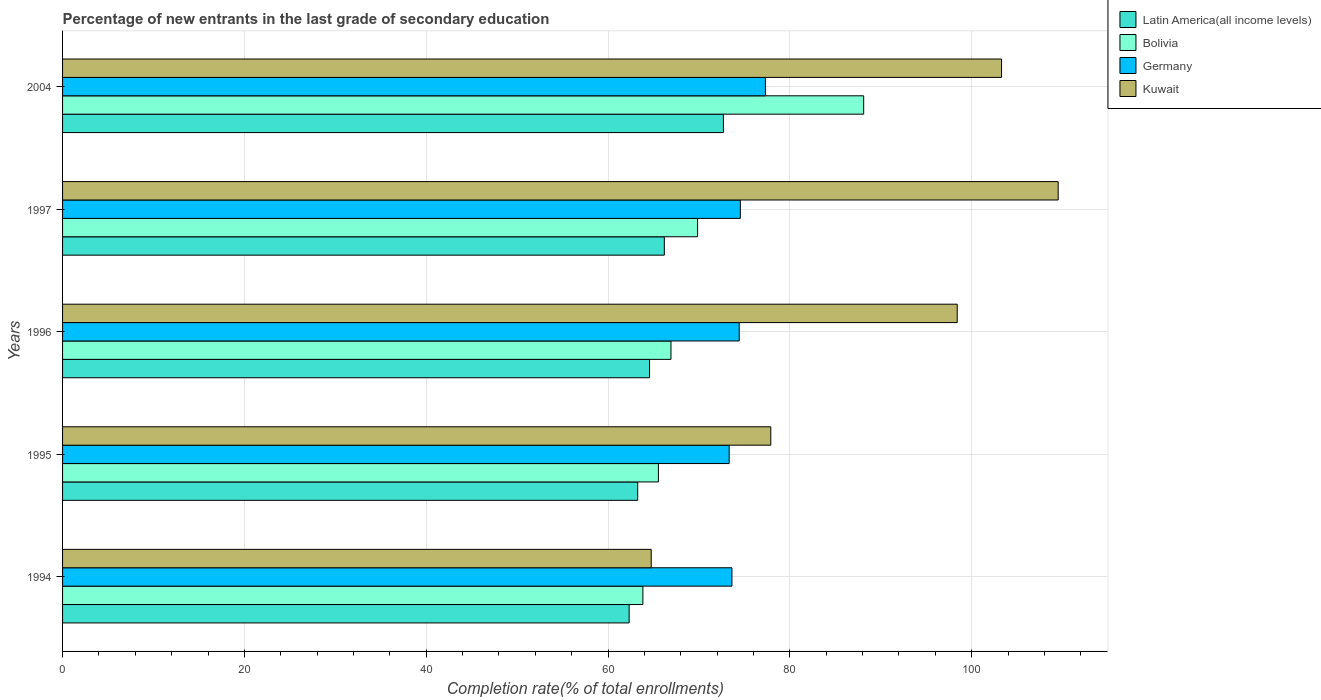How many different coloured bars are there?
Offer a terse response. 4. How many groups of bars are there?
Provide a succinct answer. 5. Are the number of bars on each tick of the Y-axis equal?
Keep it short and to the point. Yes. How many bars are there on the 4th tick from the bottom?
Give a very brief answer. 4. What is the label of the 4th group of bars from the top?
Offer a terse response. 1995. In how many cases, is the number of bars for a given year not equal to the number of legend labels?
Your response must be concise. 0. What is the percentage of new entrants in Kuwait in 1994?
Your answer should be very brief. 64.75. Across all years, what is the maximum percentage of new entrants in Germany?
Provide a succinct answer. 77.31. Across all years, what is the minimum percentage of new entrants in Germany?
Make the answer very short. 73.32. What is the total percentage of new entrants in Germany in the graph?
Offer a terse response. 373.24. What is the difference between the percentage of new entrants in Bolivia in 1997 and that in 2004?
Your answer should be very brief. -18.27. What is the difference between the percentage of new entrants in Kuwait in 1994 and the percentage of new entrants in Latin America(all income levels) in 1996?
Your answer should be very brief. 0.18. What is the average percentage of new entrants in Latin America(all income levels) per year?
Provide a short and direct response. 65.81. In the year 1994, what is the difference between the percentage of new entrants in Bolivia and percentage of new entrants in Germany?
Give a very brief answer. -9.79. What is the ratio of the percentage of new entrants in Kuwait in 1997 to that in 2004?
Provide a short and direct response. 1.06. What is the difference between the highest and the second highest percentage of new entrants in Kuwait?
Provide a short and direct response. 6.23. What is the difference between the highest and the lowest percentage of new entrants in Latin America(all income levels)?
Ensure brevity in your answer.  10.37. Is the sum of the percentage of new entrants in Latin America(all income levels) in 1995 and 1997 greater than the maximum percentage of new entrants in Bolivia across all years?
Make the answer very short. Yes. Is it the case that in every year, the sum of the percentage of new entrants in Latin America(all income levels) and percentage of new entrants in Germany is greater than the sum of percentage of new entrants in Kuwait and percentage of new entrants in Bolivia?
Your response must be concise. No. What does the 4th bar from the top in 2004 represents?
Your answer should be compact. Latin America(all income levels). What does the 2nd bar from the bottom in 1996 represents?
Your answer should be very brief. Bolivia. Are all the bars in the graph horizontal?
Provide a short and direct response. Yes. How many years are there in the graph?
Give a very brief answer. 5. What is the difference between two consecutive major ticks on the X-axis?
Provide a succinct answer. 20. Are the values on the major ticks of X-axis written in scientific E-notation?
Keep it short and to the point. No. Does the graph contain any zero values?
Your answer should be very brief. No. Does the graph contain grids?
Offer a terse response. Yes. How are the legend labels stacked?
Make the answer very short. Vertical. What is the title of the graph?
Make the answer very short. Percentage of new entrants in the last grade of secondary education. Does "Cuba" appear as one of the legend labels in the graph?
Offer a very short reply. No. What is the label or title of the X-axis?
Offer a very short reply. Completion rate(% of total enrollments). What is the Completion rate(% of total enrollments) in Latin America(all income levels) in 1994?
Your answer should be very brief. 62.32. What is the Completion rate(% of total enrollments) in Bolivia in 1994?
Give a very brief answer. 63.83. What is the Completion rate(% of total enrollments) of Germany in 1994?
Your answer should be very brief. 73.63. What is the Completion rate(% of total enrollments) in Kuwait in 1994?
Your answer should be compact. 64.75. What is the Completion rate(% of total enrollments) in Latin America(all income levels) in 1995?
Your answer should be very brief. 63.26. What is the Completion rate(% of total enrollments) of Bolivia in 1995?
Offer a very short reply. 65.54. What is the Completion rate(% of total enrollments) in Germany in 1995?
Your response must be concise. 73.32. What is the Completion rate(% of total enrollments) in Kuwait in 1995?
Give a very brief answer. 77.9. What is the Completion rate(% of total enrollments) in Latin America(all income levels) in 1996?
Offer a terse response. 64.57. What is the Completion rate(% of total enrollments) of Bolivia in 1996?
Keep it short and to the point. 66.92. What is the Completion rate(% of total enrollments) of Germany in 1996?
Your answer should be compact. 74.43. What is the Completion rate(% of total enrollments) of Kuwait in 1996?
Give a very brief answer. 98.41. What is the Completion rate(% of total enrollments) of Latin America(all income levels) in 1997?
Your answer should be compact. 66.19. What is the Completion rate(% of total enrollments) in Bolivia in 1997?
Provide a short and direct response. 69.85. What is the Completion rate(% of total enrollments) of Germany in 1997?
Your answer should be very brief. 74.55. What is the Completion rate(% of total enrollments) in Kuwait in 1997?
Offer a very short reply. 109.51. What is the Completion rate(% of total enrollments) of Latin America(all income levels) in 2004?
Provide a succinct answer. 72.69. What is the Completion rate(% of total enrollments) in Bolivia in 2004?
Provide a short and direct response. 88.12. What is the Completion rate(% of total enrollments) in Germany in 2004?
Keep it short and to the point. 77.31. What is the Completion rate(% of total enrollments) in Kuwait in 2004?
Offer a very short reply. 103.29. Across all years, what is the maximum Completion rate(% of total enrollments) of Latin America(all income levels)?
Your response must be concise. 72.69. Across all years, what is the maximum Completion rate(% of total enrollments) in Bolivia?
Provide a short and direct response. 88.12. Across all years, what is the maximum Completion rate(% of total enrollments) of Germany?
Provide a short and direct response. 77.31. Across all years, what is the maximum Completion rate(% of total enrollments) of Kuwait?
Provide a short and direct response. 109.51. Across all years, what is the minimum Completion rate(% of total enrollments) in Latin America(all income levels)?
Your answer should be very brief. 62.32. Across all years, what is the minimum Completion rate(% of total enrollments) of Bolivia?
Your answer should be compact. 63.83. Across all years, what is the minimum Completion rate(% of total enrollments) of Germany?
Provide a short and direct response. 73.32. Across all years, what is the minimum Completion rate(% of total enrollments) of Kuwait?
Make the answer very short. 64.75. What is the total Completion rate(% of total enrollments) of Latin America(all income levels) in the graph?
Your response must be concise. 329.04. What is the total Completion rate(% of total enrollments) in Bolivia in the graph?
Keep it short and to the point. 354.27. What is the total Completion rate(% of total enrollments) of Germany in the graph?
Offer a very short reply. 373.24. What is the total Completion rate(% of total enrollments) in Kuwait in the graph?
Make the answer very short. 453.86. What is the difference between the Completion rate(% of total enrollments) in Latin America(all income levels) in 1994 and that in 1995?
Provide a short and direct response. -0.94. What is the difference between the Completion rate(% of total enrollments) of Bolivia in 1994 and that in 1995?
Provide a short and direct response. -1.71. What is the difference between the Completion rate(% of total enrollments) of Germany in 1994 and that in 1995?
Ensure brevity in your answer.  0.3. What is the difference between the Completion rate(% of total enrollments) in Kuwait in 1994 and that in 1995?
Offer a terse response. -13.15. What is the difference between the Completion rate(% of total enrollments) in Latin America(all income levels) in 1994 and that in 1996?
Your answer should be very brief. -2.25. What is the difference between the Completion rate(% of total enrollments) of Bolivia in 1994 and that in 1996?
Your answer should be compact. -3.09. What is the difference between the Completion rate(% of total enrollments) of Germany in 1994 and that in 1996?
Ensure brevity in your answer.  -0.8. What is the difference between the Completion rate(% of total enrollments) in Kuwait in 1994 and that in 1996?
Make the answer very short. -33.66. What is the difference between the Completion rate(% of total enrollments) in Latin America(all income levels) in 1994 and that in 1997?
Your response must be concise. -3.87. What is the difference between the Completion rate(% of total enrollments) of Bolivia in 1994 and that in 1997?
Keep it short and to the point. -6.02. What is the difference between the Completion rate(% of total enrollments) in Germany in 1994 and that in 1997?
Your answer should be very brief. -0.93. What is the difference between the Completion rate(% of total enrollments) in Kuwait in 1994 and that in 1997?
Make the answer very short. -44.76. What is the difference between the Completion rate(% of total enrollments) in Latin America(all income levels) in 1994 and that in 2004?
Your response must be concise. -10.37. What is the difference between the Completion rate(% of total enrollments) of Bolivia in 1994 and that in 2004?
Offer a very short reply. -24.29. What is the difference between the Completion rate(% of total enrollments) in Germany in 1994 and that in 2004?
Your response must be concise. -3.68. What is the difference between the Completion rate(% of total enrollments) of Kuwait in 1994 and that in 2004?
Provide a short and direct response. -38.54. What is the difference between the Completion rate(% of total enrollments) of Latin America(all income levels) in 1995 and that in 1996?
Your answer should be compact. -1.3. What is the difference between the Completion rate(% of total enrollments) in Bolivia in 1995 and that in 1996?
Make the answer very short. -1.38. What is the difference between the Completion rate(% of total enrollments) in Germany in 1995 and that in 1996?
Your answer should be very brief. -1.1. What is the difference between the Completion rate(% of total enrollments) of Kuwait in 1995 and that in 1996?
Ensure brevity in your answer.  -20.51. What is the difference between the Completion rate(% of total enrollments) of Latin America(all income levels) in 1995 and that in 1997?
Give a very brief answer. -2.93. What is the difference between the Completion rate(% of total enrollments) in Bolivia in 1995 and that in 1997?
Your answer should be very brief. -4.31. What is the difference between the Completion rate(% of total enrollments) of Germany in 1995 and that in 1997?
Offer a terse response. -1.23. What is the difference between the Completion rate(% of total enrollments) in Kuwait in 1995 and that in 1997?
Offer a terse response. -31.61. What is the difference between the Completion rate(% of total enrollments) of Latin America(all income levels) in 1995 and that in 2004?
Your response must be concise. -9.43. What is the difference between the Completion rate(% of total enrollments) of Bolivia in 1995 and that in 2004?
Provide a short and direct response. -22.58. What is the difference between the Completion rate(% of total enrollments) in Germany in 1995 and that in 2004?
Provide a succinct answer. -3.98. What is the difference between the Completion rate(% of total enrollments) of Kuwait in 1995 and that in 2004?
Your answer should be compact. -25.38. What is the difference between the Completion rate(% of total enrollments) of Latin America(all income levels) in 1996 and that in 1997?
Give a very brief answer. -1.62. What is the difference between the Completion rate(% of total enrollments) of Bolivia in 1996 and that in 1997?
Offer a very short reply. -2.93. What is the difference between the Completion rate(% of total enrollments) in Germany in 1996 and that in 1997?
Your answer should be compact. -0.13. What is the difference between the Completion rate(% of total enrollments) of Kuwait in 1996 and that in 1997?
Give a very brief answer. -11.1. What is the difference between the Completion rate(% of total enrollments) of Latin America(all income levels) in 1996 and that in 2004?
Offer a terse response. -8.12. What is the difference between the Completion rate(% of total enrollments) in Bolivia in 1996 and that in 2004?
Keep it short and to the point. -21.2. What is the difference between the Completion rate(% of total enrollments) of Germany in 1996 and that in 2004?
Offer a very short reply. -2.88. What is the difference between the Completion rate(% of total enrollments) of Kuwait in 1996 and that in 2004?
Ensure brevity in your answer.  -4.88. What is the difference between the Completion rate(% of total enrollments) in Latin America(all income levels) in 1997 and that in 2004?
Provide a short and direct response. -6.5. What is the difference between the Completion rate(% of total enrollments) of Bolivia in 1997 and that in 2004?
Your answer should be very brief. -18.27. What is the difference between the Completion rate(% of total enrollments) of Germany in 1997 and that in 2004?
Your answer should be compact. -2.75. What is the difference between the Completion rate(% of total enrollments) in Kuwait in 1997 and that in 2004?
Keep it short and to the point. 6.23. What is the difference between the Completion rate(% of total enrollments) of Latin America(all income levels) in 1994 and the Completion rate(% of total enrollments) of Bolivia in 1995?
Your response must be concise. -3.22. What is the difference between the Completion rate(% of total enrollments) of Latin America(all income levels) in 1994 and the Completion rate(% of total enrollments) of Germany in 1995?
Your answer should be compact. -11. What is the difference between the Completion rate(% of total enrollments) of Latin America(all income levels) in 1994 and the Completion rate(% of total enrollments) of Kuwait in 1995?
Your answer should be very brief. -15.58. What is the difference between the Completion rate(% of total enrollments) in Bolivia in 1994 and the Completion rate(% of total enrollments) in Germany in 1995?
Keep it short and to the point. -9.49. What is the difference between the Completion rate(% of total enrollments) in Bolivia in 1994 and the Completion rate(% of total enrollments) in Kuwait in 1995?
Provide a succinct answer. -14.07. What is the difference between the Completion rate(% of total enrollments) of Germany in 1994 and the Completion rate(% of total enrollments) of Kuwait in 1995?
Your response must be concise. -4.28. What is the difference between the Completion rate(% of total enrollments) in Latin America(all income levels) in 1994 and the Completion rate(% of total enrollments) in Bolivia in 1996?
Make the answer very short. -4.6. What is the difference between the Completion rate(% of total enrollments) of Latin America(all income levels) in 1994 and the Completion rate(% of total enrollments) of Germany in 1996?
Ensure brevity in your answer.  -12.11. What is the difference between the Completion rate(% of total enrollments) of Latin America(all income levels) in 1994 and the Completion rate(% of total enrollments) of Kuwait in 1996?
Ensure brevity in your answer.  -36.09. What is the difference between the Completion rate(% of total enrollments) of Bolivia in 1994 and the Completion rate(% of total enrollments) of Germany in 1996?
Keep it short and to the point. -10.59. What is the difference between the Completion rate(% of total enrollments) of Bolivia in 1994 and the Completion rate(% of total enrollments) of Kuwait in 1996?
Your answer should be compact. -34.58. What is the difference between the Completion rate(% of total enrollments) in Germany in 1994 and the Completion rate(% of total enrollments) in Kuwait in 1996?
Offer a very short reply. -24.78. What is the difference between the Completion rate(% of total enrollments) of Latin America(all income levels) in 1994 and the Completion rate(% of total enrollments) of Bolivia in 1997?
Your answer should be compact. -7.53. What is the difference between the Completion rate(% of total enrollments) of Latin America(all income levels) in 1994 and the Completion rate(% of total enrollments) of Germany in 1997?
Offer a terse response. -12.23. What is the difference between the Completion rate(% of total enrollments) of Latin America(all income levels) in 1994 and the Completion rate(% of total enrollments) of Kuwait in 1997?
Make the answer very short. -47.19. What is the difference between the Completion rate(% of total enrollments) in Bolivia in 1994 and the Completion rate(% of total enrollments) in Germany in 1997?
Provide a short and direct response. -10.72. What is the difference between the Completion rate(% of total enrollments) in Bolivia in 1994 and the Completion rate(% of total enrollments) in Kuwait in 1997?
Keep it short and to the point. -45.68. What is the difference between the Completion rate(% of total enrollments) of Germany in 1994 and the Completion rate(% of total enrollments) of Kuwait in 1997?
Provide a short and direct response. -35.88. What is the difference between the Completion rate(% of total enrollments) in Latin America(all income levels) in 1994 and the Completion rate(% of total enrollments) in Bolivia in 2004?
Provide a short and direct response. -25.8. What is the difference between the Completion rate(% of total enrollments) of Latin America(all income levels) in 1994 and the Completion rate(% of total enrollments) of Germany in 2004?
Offer a terse response. -14.99. What is the difference between the Completion rate(% of total enrollments) in Latin America(all income levels) in 1994 and the Completion rate(% of total enrollments) in Kuwait in 2004?
Provide a succinct answer. -40.96. What is the difference between the Completion rate(% of total enrollments) of Bolivia in 1994 and the Completion rate(% of total enrollments) of Germany in 2004?
Provide a short and direct response. -13.47. What is the difference between the Completion rate(% of total enrollments) of Bolivia in 1994 and the Completion rate(% of total enrollments) of Kuwait in 2004?
Your response must be concise. -39.45. What is the difference between the Completion rate(% of total enrollments) of Germany in 1994 and the Completion rate(% of total enrollments) of Kuwait in 2004?
Offer a terse response. -29.66. What is the difference between the Completion rate(% of total enrollments) in Latin America(all income levels) in 1995 and the Completion rate(% of total enrollments) in Bolivia in 1996?
Your answer should be very brief. -3.66. What is the difference between the Completion rate(% of total enrollments) in Latin America(all income levels) in 1995 and the Completion rate(% of total enrollments) in Germany in 1996?
Make the answer very short. -11.16. What is the difference between the Completion rate(% of total enrollments) of Latin America(all income levels) in 1995 and the Completion rate(% of total enrollments) of Kuwait in 1996?
Give a very brief answer. -35.15. What is the difference between the Completion rate(% of total enrollments) in Bolivia in 1995 and the Completion rate(% of total enrollments) in Germany in 1996?
Give a very brief answer. -8.89. What is the difference between the Completion rate(% of total enrollments) in Bolivia in 1995 and the Completion rate(% of total enrollments) in Kuwait in 1996?
Provide a short and direct response. -32.87. What is the difference between the Completion rate(% of total enrollments) of Germany in 1995 and the Completion rate(% of total enrollments) of Kuwait in 1996?
Keep it short and to the point. -25.09. What is the difference between the Completion rate(% of total enrollments) in Latin America(all income levels) in 1995 and the Completion rate(% of total enrollments) in Bolivia in 1997?
Offer a very short reply. -6.59. What is the difference between the Completion rate(% of total enrollments) in Latin America(all income levels) in 1995 and the Completion rate(% of total enrollments) in Germany in 1997?
Provide a short and direct response. -11.29. What is the difference between the Completion rate(% of total enrollments) in Latin America(all income levels) in 1995 and the Completion rate(% of total enrollments) in Kuwait in 1997?
Offer a terse response. -46.25. What is the difference between the Completion rate(% of total enrollments) of Bolivia in 1995 and the Completion rate(% of total enrollments) of Germany in 1997?
Your response must be concise. -9.01. What is the difference between the Completion rate(% of total enrollments) in Bolivia in 1995 and the Completion rate(% of total enrollments) in Kuwait in 1997?
Offer a very short reply. -43.97. What is the difference between the Completion rate(% of total enrollments) in Germany in 1995 and the Completion rate(% of total enrollments) in Kuwait in 1997?
Give a very brief answer. -36.19. What is the difference between the Completion rate(% of total enrollments) of Latin America(all income levels) in 1995 and the Completion rate(% of total enrollments) of Bolivia in 2004?
Make the answer very short. -24.86. What is the difference between the Completion rate(% of total enrollments) in Latin America(all income levels) in 1995 and the Completion rate(% of total enrollments) in Germany in 2004?
Give a very brief answer. -14.04. What is the difference between the Completion rate(% of total enrollments) in Latin America(all income levels) in 1995 and the Completion rate(% of total enrollments) in Kuwait in 2004?
Provide a short and direct response. -40.02. What is the difference between the Completion rate(% of total enrollments) of Bolivia in 1995 and the Completion rate(% of total enrollments) of Germany in 2004?
Make the answer very short. -11.77. What is the difference between the Completion rate(% of total enrollments) in Bolivia in 1995 and the Completion rate(% of total enrollments) in Kuwait in 2004?
Your answer should be compact. -37.75. What is the difference between the Completion rate(% of total enrollments) in Germany in 1995 and the Completion rate(% of total enrollments) in Kuwait in 2004?
Ensure brevity in your answer.  -29.96. What is the difference between the Completion rate(% of total enrollments) of Latin America(all income levels) in 1996 and the Completion rate(% of total enrollments) of Bolivia in 1997?
Provide a short and direct response. -5.28. What is the difference between the Completion rate(% of total enrollments) in Latin America(all income levels) in 1996 and the Completion rate(% of total enrollments) in Germany in 1997?
Offer a terse response. -9.99. What is the difference between the Completion rate(% of total enrollments) in Latin America(all income levels) in 1996 and the Completion rate(% of total enrollments) in Kuwait in 1997?
Provide a succinct answer. -44.95. What is the difference between the Completion rate(% of total enrollments) in Bolivia in 1996 and the Completion rate(% of total enrollments) in Germany in 1997?
Your answer should be very brief. -7.63. What is the difference between the Completion rate(% of total enrollments) in Bolivia in 1996 and the Completion rate(% of total enrollments) in Kuwait in 1997?
Your answer should be compact. -42.59. What is the difference between the Completion rate(% of total enrollments) in Germany in 1996 and the Completion rate(% of total enrollments) in Kuwait in 1997?
Make the answer very short. -35.08. What is the difference between the Completion rate(% of total enrollments) of Latin America(all income levels) in 1996 and the Completion rate(% of total enrollments) of Bolivia in 2004?
Your answer should be very brief. -23.55. What is the difference between the Completion rate(% of total enrollments) of Latin America(all income levels) in 1996 and the Completion rate(% of total enrollments) of Germany in 2004?
Make the answer very short. -12.74. What is the difference between the Completion rate(% of total enrollments) in Latin America(all income levels) in 1996 and the Completion rate(% of total enrollments) in Kuwait in 2004?
Your response must be concise. -38.72. What is the difference between the Completion rate(% of total enrollments) in Bolivia in 1996 and the Completion rate(% of total enrollments) in Germany in 2004?
Provide a short and direct response. -10.39. What is the difference between the Completion rate(% of total enrollments) of Bolivia in 1996 and the Completion rate(% of total enrollments) of Kuwait in 2004?
Give a very brief answer. -36.36. What is the difference between the Completion rate(% of total enrollments) of Germany in 1996 and the Completion rate(% of total enrollments) of Kuwait in 2004?
Provide a short and direct response. -28.86. What is the difference between the Completion rate(% of total enrollments) of Latin America(all income levels) in 1997 and the Completion rate(% of total enrollments) of Bolivia in 2004?
Your response must be concise. -21.93. What is the difference between the Completion rate(% of total enrollments) of Latin America(all income levels) in 1997 and the Completion rate(% of total enrollments) of Germany in 2004?
Keep it short and to the point. -11.12. What is the difference between the Completion rate(% of total enrollments) of Latin America(all income levels) in 1997 and the Completion rate(% of total enrollments) of Kuwait in 2004?
Make the answer very short. -37.09. What is the difference between the Completion rate(% of total enrollments) in Bolivia in 1997 and the Completion rate(% of total enrollments) in Germany in 2004?
Your answer should be compact. -7.46. What is the difference between the Completion rate(% of total enrollments) of Bolivia in 1997 and the Completion rate(% of total enrollments) of Kuwait in 2004?
Your response must be concise. -33.44. What is the difference between the Completion rate(% of total enrollments) of Germany in 1997 and the Completion rate(% of total enrollments) of Kuwait in 2004?
Your answer should be very brief. -28.73. What is the average Completion rate(% of total enrollments) in Latin America(all income levels) per year?
Your response must be concise. 65.81. What is the average Completion rate(% of total enrollments) of Bolivia per year?
Keep it short and to the point. 70.85. What is the average Completion rate(% of total enrollments) in Germany per year?
Offer a very short reply. 74.65. What is the average Completion rate(% of total enrollments) in Kuwait per year?
Give a very brief answer. 90.77. In the year 1994, what is the difference between the Completion rate(% of total enrollments) of Latin America(all income levels) and Completion rate(% of total enrollments) of Bolivia?
Your answer should be compact. -1.51. In the year 1994, what is the difference between the Completion rate(% of total enrollments) of Latin America(all income levels) and Completion rate(% of total enrollments) of Germany?
Give a very brief answer. -11.31. In the year 1994, what is the difference between the Completion rate(% of total enrollments) in Latin America(all income levels) and Completion rate(% of total enrollments) in Kuwait?
Your answer should be compact. -2.43. In the year 1994, what is the difference between the Completion rate(% of total enrollments) of Bolivia and Completion rate(% of total enrollments) of Germany?
Your response must be concise. -9.79. In the year 1994, what is the difference between the Completion rate(% of total enrollments) of Bolivia and Completion rate(% of total enrollments) of Kuwait?
Your answer should be compact. -0.92. In the year 1994, what is the difference between the Completion rate(% of total enrollments) in Germany and Completion rate(% of total enrollments) in Kuwait?
Provide a succinct answer. 8.88. In the year 1995, what is the difference between the Completion rate(% of total enrollments) of Latin America(all income levels) and Completion rate(% of total enrollments) of Bolivia?
Your answer should be compact. -2.28. In the year 1995, what is the difference between the Completion rate(% of total enrollments) in Latin America(all income levels) and Completion rate(% of total enrollments) in Germany?
Provide a succinct answer. -10.06. In the year 1995, what is the difference between the Completion rate(% of total enrollments) in Latin America(all income levels) and Completion rate(% of total enrollments) in Kuwait?
Offer a very short reply. -14.64. In the year 1995, what is the difference between the Completion rate(% of total enrollments) of Bolivia and Completion rate(% of total enrollments) of Germany?
Your response must be concise. -7.78. In the year 1995, what is the difference between the Completion rate(% of total enrollments) of Bolivia and Completion rate(% of total enrollments) of Kuwait?
Give a very brief answer. -12.36. In the year 1995, what is the difference between the Completion rate(% of total enrollments) of Germany and Completion rate(% of total enrollments) of Kuwait?
Make the answer very short. -4.58. In the year 1996, what is the difference between the Completion rate(% of total enrollments) in Latin America(all income levels) and Completion rate(% of total enrollments) in Bolivia?
Provide a short and direct response. -2.36. In the year 1996, what is the difference between the Completion rate(% of total enrollments) of Latin America(all income levels) and Completion rate(% of total enrollments) of Germany?
Make the answer very short. -9.86. In the year 1996, what is the difference between the Completion rate(% of total enrollments) in Latin America(all income levels) and Completion rate(% of total enrollments) in Kuwait?
Ensure brevity in your answer.  -33.84. In the year 1996, what is the difference between the Completion rate(% of total enrollments) of Bolivia and Completion rate(% of total enrollments) of Germany?
Keep it short and to the point. -7.51. In the year 1996, what is the difference between the Completion rate(% of total enrollments) in Bolivia and Completion rate(% of total enrollments) in Kuwait?
Your answer should be very brief. -31.49. In the year 1996, what is the difference between the Completion rate(% of total enrollments) in Germany and Completion rate(% of total enrollments) in Kuwait?
Give a very brief answer. -23.98. In the year 1997, what is the difference between the Completion rate(% of total enrollments) in Latin America(all income levels) and Completion rate(% of total enrollments) in Bolivia?
Provide a short and direct response. -3.66. In the year 1997, what is the difference between the Completion rate(% of total enrollments) of Latin America(all income levels) and Completion rate(% of total enrollments) of Germany?
Make the answer very short. -8.36. In the year 1997, what is the difference between the Completion rate(% of total enrollments) of Latin America(all income levels) and Completion rate(% of total enrollments) of Kuwait?
Provide a succinct answer. -43.32. In the year 1997, what is the difference between the Completion rate(% of total enrollments) in Bolivia and Completion rate(% of total enrollments) in Germany?
Offer a very short reply. -4.7. In the year 1997, what is the difference between the Completion rate(% of total enrollments) in Bolivia and Completion rate(% of total enrollments) in Kuwait?
Offer a very short reply. -39.66. In the year 1997, what is the difference between the Completion rate(% of total enrollments) in Germany and Completion rate(% of total enrollments) in Kuwait?
Provide a succinct answer. -34.96. In the year 2004, what is the difference between the Completion rate(% of total enrollments) of Latin America(all income levels) and Completion rate(% of total enrollments) of Bolivia?
Offer a very short reply. -15.43. In the year 2004, what is the difference between the Completion rate(% of total enrollments) of Latin America(all income levels) and Completion rate(% of total enrollments) of Germany?
Provide a short and direct response. -4.62. In the year 2004, what is the difference between the Completion rate(% of total enrollments) in Latin America(all income levels) and Completion rate(% of total enrollments) in Kuwait?
Your response must be concise. -30.6. In the year 2004, what is the difference between the Completion rate(% of total enrollments) in Bolivia and Completion rate(% of total enrollments) in Germany?
Give a very brief answer. 10.81. In the year 2004, what is the difference between the Completion rate(% of total enrollments) in Bolivia and Completion rate(% of total enrollments) in Kuwait?
Offer a very short reply. -15.17. In the year 2004, what is the difference between the Completion rate(% of total enrollments) of Germany and Completion rate(% of total enrollments) of Kuwait?
Provide a short and direct response. -25.98. What is the ratio of the Completion rate(% of total enrollments) of Latin America(all income levels) in 1994 to that in 1995?
Ensure brevity in your answer.  0.99. What is the ratio of the Completion rate(% of total enrollments) of Kuwait in 1994 to that in 1995?
Make the answer very short. 0.83. What is the ratio of the Completion rate(% of total enrollments) of Latin America(all income levels) in 1994 to that in 1996?
Offer a very short reply. 0.97. What is the ratio of the Completion rate(% of total enrollments) of Bolivia in 1994 to that in 1996?
Your response must be concise. 0.95. What is the ratio of the Completion rate(% of total enrollments) of Germany in 1994 to that in 1996?
Provide a succinct answer. 0.99. What is the ratio of the Completion rate(% of total enrollments) in Kuwait in 1994 to that in 1996?
Provide a short and direct response. 0.66. What is the ratio of the Completion rate(% of total enrollments) in Latin America(all income levels) in 1994 to that in 1997?
Provide a short and direct response. 0.94. What is the ratio of the Completion rate(% of total enrollments) in Bolivia in 1994 to that in 1997?
Your response must be concise. 0.91. What is the ratio of the Completion rate(% of total enrollments) in Germany in 1994 to that in 1997?
Your response must be concise. 0.99. What is the ratio of the Completion rate(% of total enrollments) in Kuwait in 1994 to that in 1997?
Keep it short and to the point. 0.59. What is the ratio of the Completion rate(% of total enrollments) of Latin America(all income levels) in 1994 to that in 2004?
Your response must be concise. 0.86. What is the ratio of the Completion rate(% of total enrollments) in Bolivia in 1994 to that in 2004?
Your answer should be compact. 0.72. What is the ratio of the Completion rate(% of total enrollments) of Kuwait in 1994 to that in 2004?
Your answer should be very brief. 0.63. What is the ratio of the Completion rate(% of total enrollments) in Latin America(all income levels) in 1995 to that in 1996?
Keep it short and to the point. 0.98. What is the ratio of the Completion rate(% of total enrollments) of Bolivia in 1995 to that in 1996?
Make the answer very short. 0.98. What is the ratio of the Completion rate(% of total enrollments) of Germany in 1995 to that in 1996?
Provide a succinct answer. 0.99. What is the ratio of the Completion rate(% of total enrollments) of Kuwait in 1995 to that in 1996?
Provide a succinct answer. 0.79. What is the ratio of the Completion rate(% of total enrollments) of Latin America(all income levels) in 1995 to that in 1997?
Your answer should be compact. 0.96. What is the ratio of the Completion rate(% of total enrollments) of Bolivia in 1995 to that in 1997?
Make the answer very short. 0.94. What is the ratio of the Completion rate(% of total enrollments) in Germany in 1995 to that in 1997?
Give a very brief answer. 0.98. What is the ratio of the Completion rate(% of total enrollments) of Kuwait in 1995 to that in 1997?
Keep it short and to the point. 0.71. What is the ratio of the Completion rate(% of total enrollments) of Latin America(all income levels) in 1995 to that in 2004?
Make the answer very short. 0.87. What is the ratio of the Completion rate(% of total enrollments) in Bolivia in 1995 to that in 2004?
Provide a short and direct response. 0.74. What is the ratio of the Completion rate(% of total enrollments) in Germany in 1995 to that in 2004?
Give a very brief answer. 0.95. What is the ratio of the Completion rate(% of total enrollments) of Kuwait in 1995 to that in 2004?
Provide a short and direct response. 0.75. What is the ratio of the Completion rate(% of total enrollments) in Latin America(all income levels) in 1996 to that in 1997?
Ensure brevity in your answer.  0.98. What is the ratio of the Completion rate(% of total enrollments) in Bolivia in 1996 to that in 1997?
Make the answer very short. 0.96. What is the ratio of the Completion rate(% of total enrollments) of Kuwait in 1996 to that in 1997?
Offer a very short reply. 0.9. What is the ratio of the Completion rate(% of total enrollments) of Latin America(all income levels) in 1996 to that in 2004?
Make the answer very short. 0.89. What is the ratio of the Completion rate(% of total enrollments) of Bolivia in 1996 to that in 2004?
Give a very brief answer. 0.76. What is the ratio of the Completion rate(% of total enrollments) in Germany in 1996 to that in 2004?
Make the answer very short. 0.96. What is the ratio of the Completion rate(% of total enrollments) in Kuwait in 1996 to that in 2004?
Make the answer very short. 0.95. What is the ratio of the Completion rate(% of total enrollments) in Latin America(all income levels) in 1997 to that in 2004?
Offer a terse response. 0.91. What is the ratio of the Completion rate(% of total enrollments) of Bolivia in 1997 to that in 2004?
Provide a short and direct response. 0.79. What is the ratio of the Completion rate(% of total enrollments) of Germany in 1997 to that in 2004?
Ensure brevity in your answer.  0.96. What is the ratio of the Completion rate(% of total enrollments) in Kuwait in 1997 to that in 2004?
Give a very brief answer. 1.06. What is the difference between the highest and the second highest Completion rate(% of total enrollments) in Latin America(all income levels)?
Provide a short and direct response. 6.5. What is the difference between the highest and the second highest Completion rate(% of total enrollments) of Bolivia?
Give a very brief answer. 18.27. What is the difference between the highest and the second highest Completion rate(% of total enrollments) in Germany?
Provide a short and direct response. 2.75. What is the difference between the highest and the second highest Completion rate(% of total enrollments) of Kuwait?
Give a very brief answer. 6.23. What is the difference between the highest and the lowest Completion rate(% of total enrollments) in Latin America(all income levels)?
Keep it short and to the point. 10.37. What is the difference between the highest and the lowest Completion rate(% of total enrollments) of Bolivia?
Provide a short and direct response. 24.29. What is the difference between the highest and the lowest Completion rate(% of total enrollments) of Germany?
Provide a succinct answer. 3.98. What is the difference between the highest and the lowest Completion rate(% of total enrollments) in Kuwait?
Your response must be concise. 44.76. 